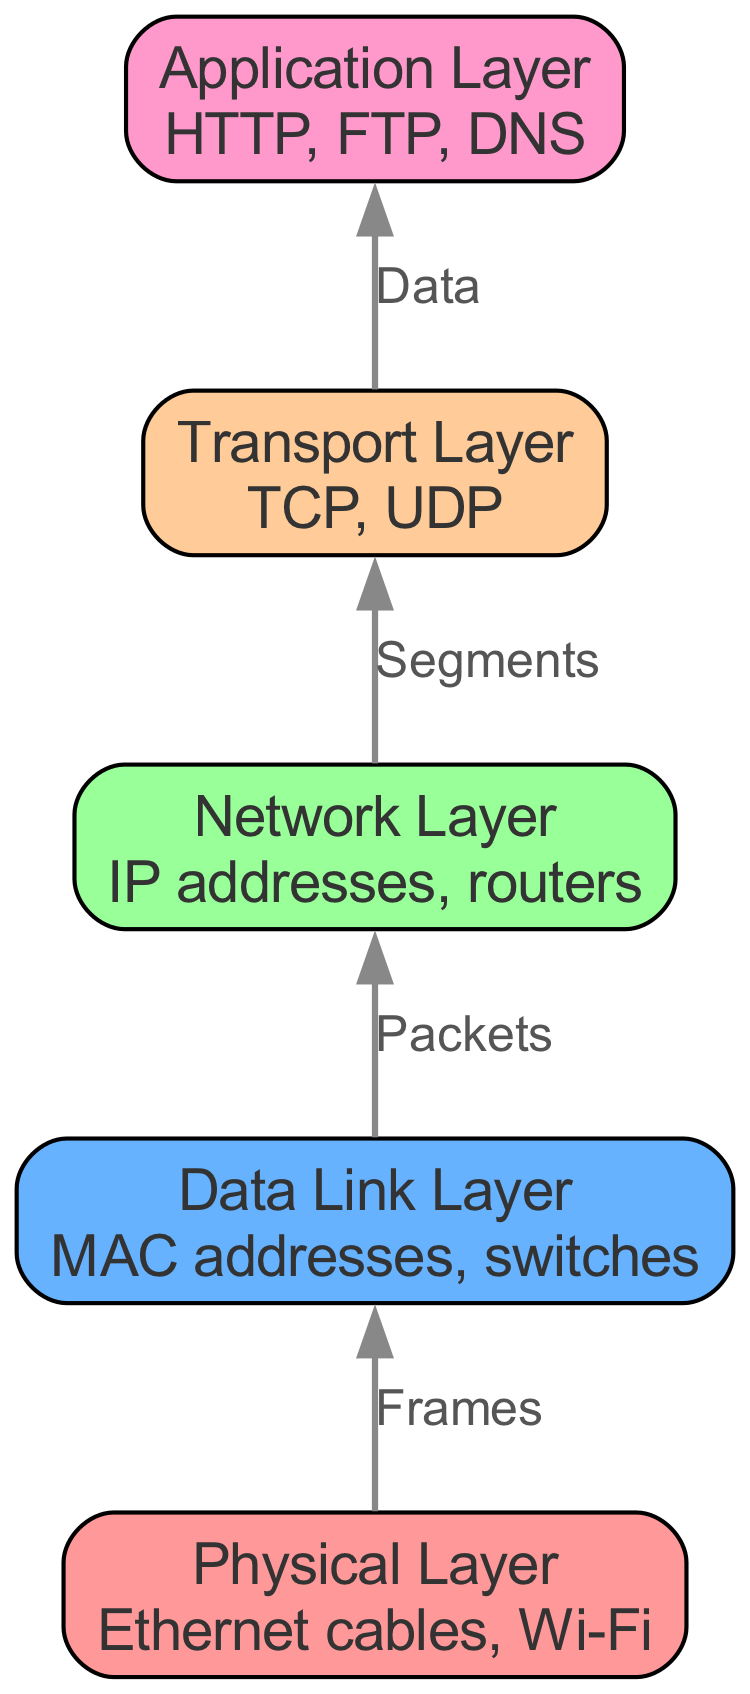What is the highest layer in the diagram? The highest layer in the diagram is identified as the "Application Layer". This is the last node listed if you start from the bottom (Physical Layer) and move upward, following the flow of the diagram.
Answer: Application Layer How many layers are represented in the diagram? The diagram shows a total of five layers. By counting the nodes provided, from the Physical Layer to the Application Layer, we find there are five distinct nodes.
Answer: 5 What is the relationship between the Data Link Layer and the Network Layer? The relationship between the Data Link Layer and the Network Layer is represented by an edge labeled "Packets". This indicates that packets flow from the Data Link Layer to the Network Layer, which is clearly illustrated in the diagram.
Answer: Packets What do we call the data unit transferred from the Network Layer to the Transport Layer? The data unit transferred from the Network Layer to the Transport Layer is called a "Segments". This is characterized by the edge connecting these two layers in the diagram, explicitly labeling the connection.
Answer: Segments Which layer uses MAC addresses? The layer that uses MAC addresses is the Data Link Layer. This information comes directly from the description associated with the Data Link Layer node in the diagram.
Answer: Data Link Layer What types of protocols are associated with the Transport Layer? The protocols associated with the Transport Layer are "TCP" and "UDP". This information is derived from the description of the Transport Layer node.
Answer: TCP, UDP How does data flow from the Transport Layer to the Application Layer? Data flows from the Transport Layer to the Application Layer utilizing the term "Data" as labeled on the connecting edge. It signifies the transfer of information from one layer to the next in the flow of the diagram.
Answer: Data Which layer serves as the foundation for the other layers? The foundation layer for the other layers is the "Physical Layer". This is the first node in the diagram, indicating its role as the base layer upon which all subsequent layers build.
Answer: Physical Layer What is represented by the edge between the Physical Layer and the Data Link Layer? The edge between the Physical Layer and the Data Link Layer is labeled "Frames". This indicates the type of data unit that is transferred as the flow progresses from Physical to Data Link Layer.
Answer: Frames 